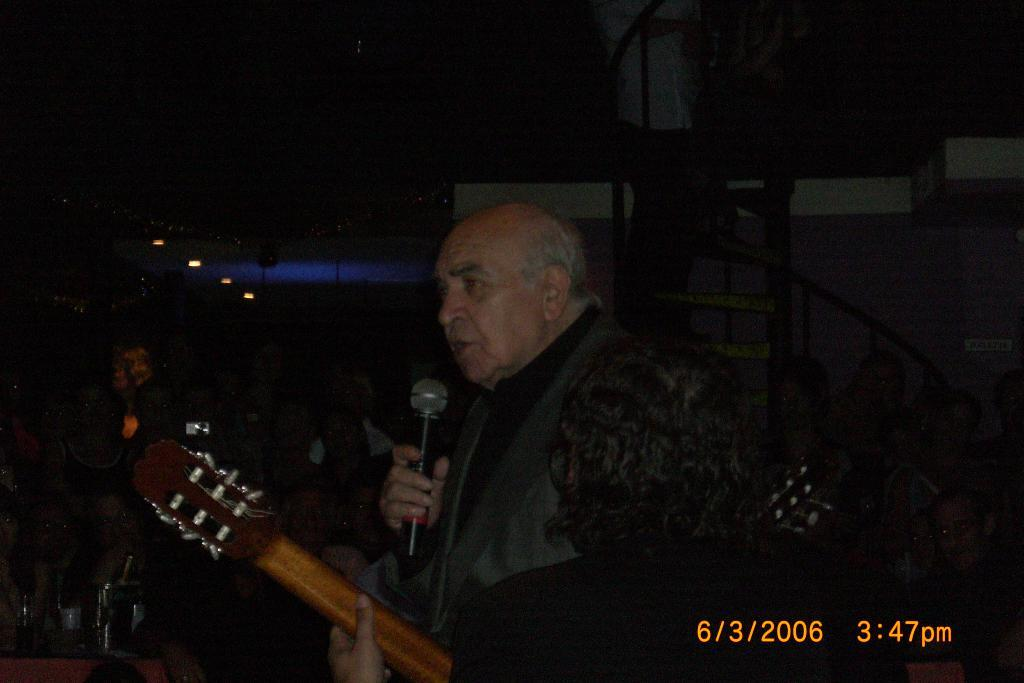How many people are visible in the image? There are two people in the image. What are the two people holding? One man is holding a microphone, and another person is holding a guitar. Can you describe the background of the image? There are additional people in the background, and there is a staircase visible. Where is the basket of flowers located in the image? There is no basket of flowers present in the image. What type of furniture can be seen in the garden in the image? There is no garden or furniture present in the image. 